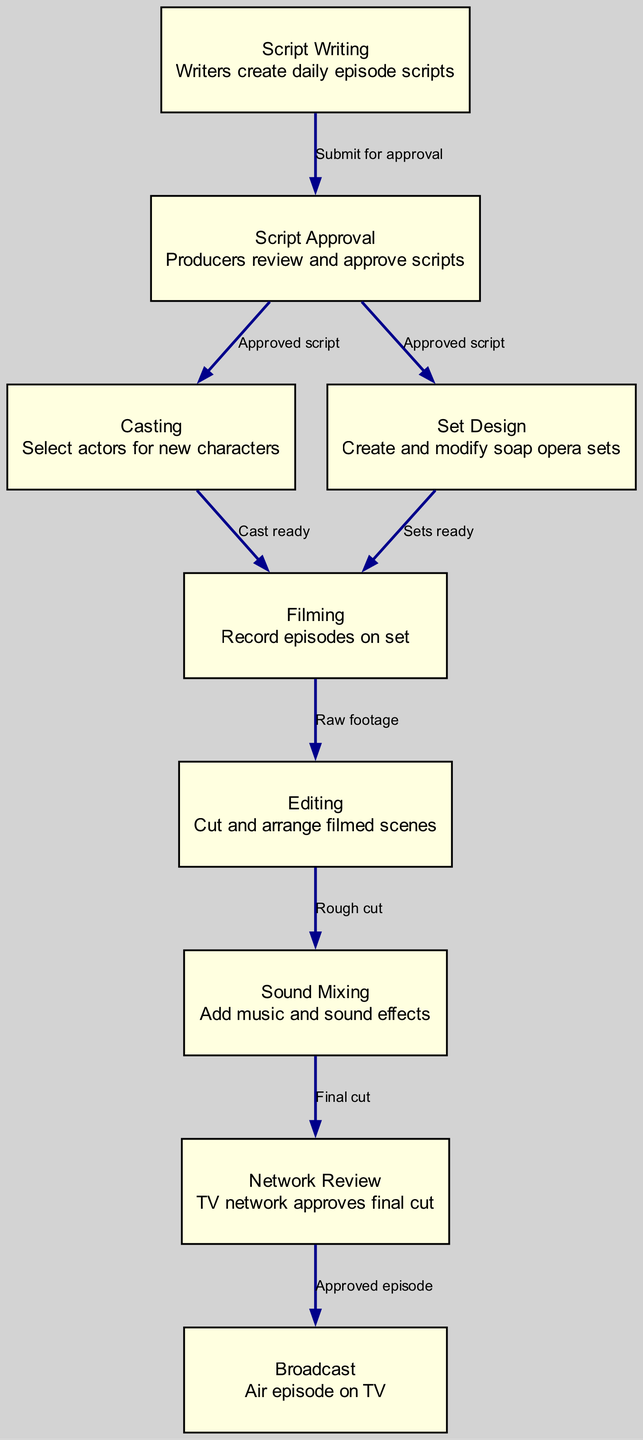What is the first step in soap opera production? The first step in the production process is "Script Writing," where writers create daily episode scripts.
Answer: Script Writing How many nodes are present in the diagram? The diagram contains 9 nodes, each representing a distinct stage in the soap opera production process.
Answer: 9 What is the final step before airing the episode? The final step before airing is "Broadcast," where the approved episode is aired on TV.
Answer: Broadcast What must happen before casting actors for a soap opera? Before casting actors, the "Script Approval" step must occur to ensure the script is finalized and ready.
Answer: Script Approval Which node follows "Sound Mixing" in the production process? The node that follows "Sound Mixing" is "Network Review," where the TV network approves the final cut of the episode.
Answer: Network Review Which two steps are dependent on the "Approved Script"? The two steps that depend on the "Approved Script" are "Casting" and "Set Design."
Answer: Casting and Set Design What is produced after filming the episodes? After filming the episodes, the result is referred to as "Raw footage." This footage then undergoes editing and sound mixing.
Answer: Raw footage What type of tasks does "Set Design" involve? "Set Design" involves creating and modifying soap opera sets to ensure they fit the narrative and visual style of the production.
Answer: Creating and modifying soap opera sets What label shows the transition from "Editing" to "Sound Mixing"? The label that shows this transition is "Rough cut," indicating that the editing stage has produced a preliminary version of the footage ready for sound mixing.
Answer: Rough cut 